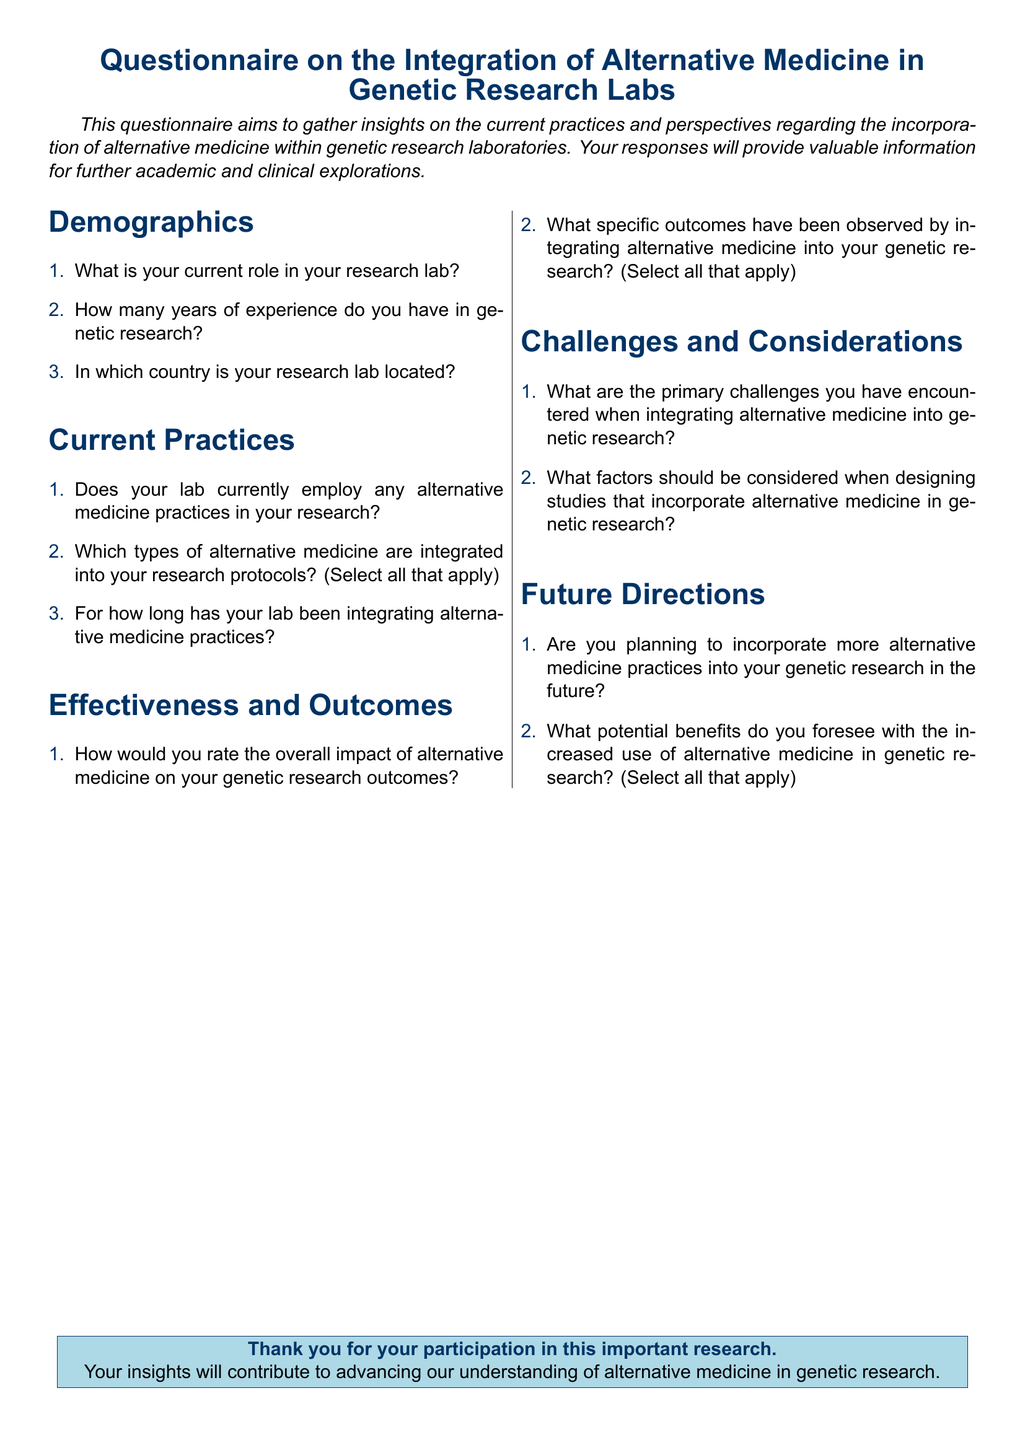What is the title of the document? The title is stated at the beginning of the document under the center heading.
Answer: Questionnaire on the Integration of Alternative Medicine in Genetic Research Labs How many sections are in the questionnaire? The sections can be counted in the document as they are clearly labeled.
Answer: Five What color is used for the document's headings? The color of the headings is specified within the document's styling.
Answer: Dark blue How many years of experience do you have in genetic research? This is one of the demographic questions posed in the questionnaire.
Answer: Open-ended response What is the primary focus of this questionnaire? The main aim of the questionnaire is described in the introductory text.
Answer: To gather insights on the current practices and perspectives regarding the incorporation of alternative medicine What is one of the categories of questions included in the questionnaire? The categories of questions are listed in the document under labeled sections.
Answer: Current Practices What kind of feedback does the questionnaire seek regarding alternative medicine? The specific feedback intentions are mentioned in the document.
Answer: Effectiveness and Outcomes Which color is used for the background of the conclusion box? The background color of the conclusion box is mentioned in the document.
Answer: Light blue Are there questions about future plans regarding alternative medicine in the questionnaire? The document includes a section focused on future directions related to alternative medicine.
Answer: Yes 